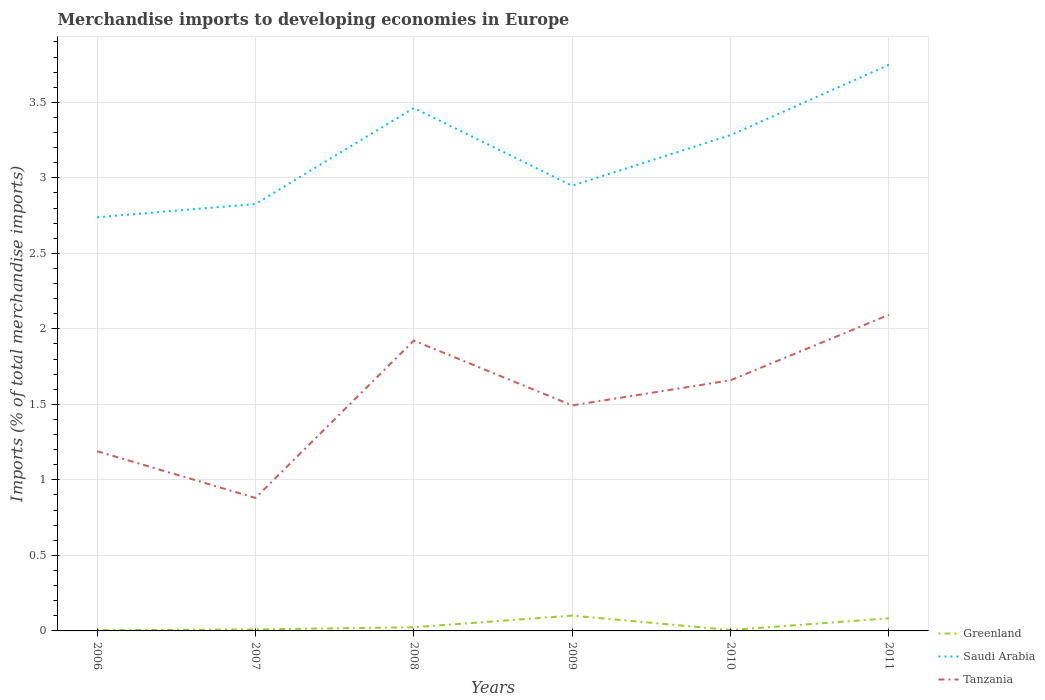Does the line corresponding to Saudi Arabia intersect with the line corresponding to Greenland?
Your answer should be compact. No. Across all years, what is the maximum percentage total merchandise imports in Tanzania?
Make the answer very short. 0.88. In which year was the percentage total merchandise imports in Greenland maximum?
Your response must be concise. 2006. What is the total percentage total merchandise imports in Saudi Arabia in the graph?
Keep it short and to the point. -0.54. What is the difference between the highest and the second highest percentage total merchandise imports in Saudi Arabia?
Your response must be concise. 1.01. What is the difference between the highest and the lowest percentage total merchandise imports in Greenland?
Offer a very short reply. 2. Is the percentage total merchandise imports in Greenland strictly greater than the percentage total merchandise imports in Tanzania over the years?
Your answer should be compact. Yes. How many years are there in the graph?
Provide a short and direct response. 6. What is the difference between two consecutive major ticks on the Y-axis?
Offer a very short reply. 0.5. Does the graph contain any zero values?
Ensure brevity in your answer.  No. Does the graph contain grids?
Ensure brevity in your answer.  Yes. Where does the legend appear in the graph?
Keep it short and to the point. Bottom right. How are the legend labels stacked?
Provide a succinct answer. Vertical. What is the title of the graph?
Offer a very short reply. Merchandise imports to developing economies in Europe. Does "Brazil" appear as one of the legend labels in the graph?
Provide a short and direct response. No. What is the label or title of the Y-axis?
Your answer should be compact. Imports (% of total merchandise imports). What is the Imports (% of total merchandise imports) of Greenland in 2006?
Ensure brevity in your answer.  0.01. What is the Imports (% of total merchandise imports) in Saudi Arabia in 2006?
Your answer should be compact. 2.74. What is the Imports (% of total merchandise imports) of Tanzania in 2006?
Offer a very short reply. 1.19. What is the Imports (% of total merchandise imports) in Greenland in 2007?
Make the answer very short. 0.01. What is the Imports (% of total merchandise imports) in Saudi Arabia in 2007?
Make the answer very short. 2.83. What is the Imports (% of total merchandise imports) in Tanzania in 2007?
Ensure brevity in your answer.  0.88. What is the Imports (% of total merchandise imports) of Greenland in 2008?
Your response must be concise. 0.02. What is the Imports (% of total merchandise imports) in Saudi Arabia in 2008?
Your answer should be very brief. 3.46. What is the Imports (% of total merchandise imports) in Tanzania in 2008?
Offer a very short reply. 1.92. What is the Imports (% of total merchandise imports) in Greenland in 2009?
Provide a short and direct response. 0.1. What is the Imports (% of total merchandise imports) of Saudi Arabia in 2009?
Provide a short and direct response. 2.95. What is the Imports (% of total merchandise imports) in Tanzania in 2009?
Offer a terse response. 1.49. What is the Imports (% of total merchandise imports) of Greenland in 2010?
Keep it short and to the point. 0.01. What is the Imports (% of total merchandise imports) in Saudi Arabia in 2010?
Ensure brevity in your answer.  3.28. What is the Imports (% of total merchandise imports) in Tanzania in 2010?
Give a very brief answer. 1.66. What is the Imports (% of total merchandise imports) of Greenland in 2011?
Provide a succinct answer. 0.08. What is the Imports (% of total merchandise imports) in Saudi Arabia in 2011?
Your answer should be compact. 3.75. What is the Imports (% of total merchandise imports) in Tanzania in 2011?
Your answer should be very brief. 2.09. Across all years, what is the maximum Imports (% of total merchandise imports) of Greenland?
Your response must be concise. 0.1. Across all years, what is the maximum Imports (% of total merchandise imports) in Saudi Arabia?
Your answer should be very brief. 3.75. Across all years, what is the maximum Imports (% of total merchandise imports) in Tanzania?
Make the answer very short. 2.09. Across all years, what is the minimum Imports (% of total merchandise imports) in Greenland?
Provide a succinct answer. 0.01. Across all years, what is the minimum Imports (% of total merchandise imports) of Saudi Arabia?
Your response must be concise. 2.74. Across all years, what is the minimum Imports (% of total merchandise imports) in Tanzania?
Your answer should be compact. 0.88. What is the total Imports (% of total merchandise imports) in Greenland in the graph?
Your answer should be very brief. 0.23. What is the total Imports (% of total merchandise imports) of Saudi Arabia in the graph?
Your answer should be compact. 19.01. What is the total Imports (% of total merchandise imports) in Tanzania in the graph?
Offer a terse response. 9.24. What is the difference between the Imports (% of total merchandise imports) in Greenland in 2006 and that in 2007?
Make the answer very short. -0. What is the difference between the Imports (% of total merchandise imports) of Saudi Arabia in 2006 and that in 2007?
Provide a short and direct response. -0.09. What is the difference between the Imports (% of total merchandise imports) of Tanzania in 2006 and that in 2007?
Offer a terse response. 0.31. What is the difference between the Imports (% of total merchandise imports) in Greenland in 2006 and that in 2008?
Give a very brief answer. -0.02. What is the difference between the Imports (% of total merchandise imports) in Saudi Arabia in 2006 and that in 2008?
Keep it short and to the point. -0.72. What is the difference between the Imports (% of total merchandise imports) of Tanzania in 2006 and that in 2008?
Your response must be concise. -0.73. What is the difference between the Imports (% of total merchandise imports) in Greenland in 2006 and that in 2009?
Provide a short and direct response. -0.1. What is the difference between the Imports (% of total merchandise imports) in Saudi Arabia in 2006 and that in 2009?
Offer a terse response. -0.21. What is the difference between the Imports (% of total merchandise imports) of Tanzania in 2006 and that in 2009?
Offer a terse response. -0.3. What is the difference between the Imports (% of total merchandise imports) of Greenland in 2006 and that in 2010?
Keep it short and to the point. -0. What is the difference between the Imports (% of total merchandise imports) in Saudi Arabia in 2006 and that in 2010?
Make the answer very short. -0.54. What is the difference between the Imports (% of total merchandise imports) of Tanzania in 2006 and that in 2010?
Ensure brevity in your answer.  -0.47. What is the difference between the Imports (% of total merchandise imports) in Greenland in 2006 and that in 2011?
Provide a short and direct response. -0.08. What is the difference between the Imports (% of total merchandise imports) in Saudi Arabia in 2006 and that in 2011?
Provide a short and direct response. -1.01. What is the difference between the Imports (% of total merchandise imports) of Tanzania in 2006 and that in 2011?
Give a very brief answer. -0.9. What is the difference between the Imports (% of total merchandise imports) of Greenland in 2007 and that in 2008?
Give a very brief answer. -0.01. What is the difference between the Imports (% of total merchandise imports) of Saudi Arabia in 2007 and that in 2008?
Your answer should be very brief. -0.64. What is the difference between the Imports (% of total merchandise imports) of Tanzania in 2007 and that in 2008?
Provide a succinct answer. -1.04. What is the difference between the Imports (% of total merchandise imports) in Greenland in 2007 and that in 2009?
Keep it short and to the point. -0.09. What is the difference between the Imports (% of total merchandise imports) in Saudi Arabia in 2007 and that in 2009?
Offer a terse response. -0.12. What is the difference between the Imports (% of total merchandise imports) in Tanzania in 2007 and that in 2009?
Ensure brevity in your answer.  -0.61. What is the difference between the Imports (% of total merchandise imports) in Greenland in 2007 and that in 2010?
Offer a very short reply. 0. What is the difference between the Imports (% of total merchandise imports) in Saudi Arabia in 2007 and that in 2010?
Provide a short and direct response. -0.46. What is the difference between the Imports (% of total merchandise imports) in Tanzania in 2007 and that in 2010?
Provide a short and direct response. -0.78. What is the difference between the Imports (% of total merchandise imports) of Greenland in 2007 and that in 2011?
Make the answer very short. -0.07. What is the difference between the Imports (% of total merchandise imports) of Saudi Arabia in 2007 and that in 2011?
Provide a short and direct response. -0.92. What is the difference between the Imports (% of total merchandise imports) in Tanzania in 2007 and that in 2011?
Your answer should be compact. -1.21. What is the difference between the Imports (% of total merchandise imports) of Greenland in 2008 and that in 2009?
Offer a very short reply. -0.08. What is the difference between the Imports (% of total merchandise imports) of Saudi Arabia in 2008 and that in 2009?
Provide a succinct answer. 0.51. What is the difference between the Imports (% of total merchandise imports) of Tanzania in 2008 and that in 2009?
Your response must be concise. 0.43. What is the difference between the Imports (% of total merchandise imports) of Greenland in 2008 and that in 2010?
Your answer should be very brief. 0.02. What is the difference between the Imports (% of total merchandise imports) of Saudi Arabia in 2008 and that in 2010?
Provide a succinct answer. 0.18. What is the difference between the Imports (% of total merchandise imports) in Tanzania in 2008 and that in 2010?
Give a very brief answer. 0.26. What is the difference between the Imports (% of total merchandise imports) of Greenland in 2008 and that in 2011?
Offer a terse response. -0.06. What is the difference between the Imports (% of total merchandise imports) of Saudi Arabia in 2008 and that in 2011?
Offer a terse response. -0.29. What is the difference between the Imports (% of total merchandise imports) in Tanzania in 2008 and that in 2011?
Make the answer very short. -0.17. What is the difference between the Imports (% of total merchandise imports) of Greenland in 2009 and that in 2010?
Give a very brief answer. 0.1. What is the difference between the Imports (% of total merchandise imports) of Saudi Arabia in 2009 and that in 2010?
Your answer should be compact. -0.33. What is the difference between the Imports (% of total merchandise imports) in Tanzania in 2009 and that in 2010?
Ensure brevity in your answer.  -0.17. What is the difference between the Imports (% of total merchandise imports) in Greenland in 2009 and that in 2011?
Your answer should be compact. 0.02. What is the difference between the Imports (% of total merchandise imports) in Saudi Arabia in 2009 and that in 2011?
Make the answer very short. -0.8. What is the difference between the Imports (% of total merchandise imports) in Tanzania in 2009 and that in 2011?
Ensure brevity in your answer.  -0.6. What is the difference between the Imports (% of total merchandise imports) of Greenland in 2010 and that in 2011?
Offer a terse response. -0.08. What is the difference between the Imports (% of total merchandise imports) in Saudi Arabia in 2010 and that in 2011?
Your response must be concise. -0.47. What is the difference between the Imports (% of total merchandise imports) of Tanzania in 2010 and that in 2011?
Keep it short and to the point. -0.43. What is the difference between the Imports (% of total merchandise imports) in Greenland in 2006 and the Imports (% of total merchandise imports) in Saudi Arabia in 2007?
Ensure brevity in your answer.  -2.82. What is the difference between the Imports (% of total merchandise imports) in Greenland in 2006 and the Imports (% of total merchandise imports) in Tanzania in 2007?
Ensure brevity in your answer.  -0.88. What is the difference between the Imports (% of total merchandise imports) of Saudi Arabia in 2006 and the Imports (% of total merchandise imports) of Tanzania in 2007?
Provide a succinct answer. 1.86. What is the difference between the Imports (% of total merchandise imports) in Greenland in 2006 and the Imports (% of total merchandise imports) in Saudi Arabia in 2008?
Provide a short and direct response. -3.46. What is the difference between the Imports (% of total merchandise imports) in Greenland in 2006 and the Imports (% of total merchandise imports) in Tanzania in 2008?
Offer a terse response. -1.92. What is the difference between the Imports (% of total merchandise imports) of Saudi Arabia in 2006 and the Imports (% of total merchandise imports) of Tanzania in 2008?
Your response must be concise. 0.82. What is the difference between the Imports (% of total merchandise imports) of Greenland in 2006 and the Imports (% of total merchandise imports) of Saudi Arabia in 2009?
Your answer should be compact. -2.94. What is the difference between the Imports (% of total merchandise imports) in Greenland in 2006 and the Imports (% of total merchandise imports) in Tanzania in 2009?
Provide a succinct answer. -1.49. What is the difference between the Imports (% of total merchandise imports) of Saudi Arabia in 2006 and the Imports (% of total merchandise imports) of Tanzania in 2009?
Make the answer very short. 1.25. What is the difference between the Imports (% of total merchandise imports) of Greenland in 2006 and the Imports (% of total merchandise imports) of Saudi Arabia in 2010?
Give a very brief answer. -3.28. What is the difference between the Imports (% of total merchandise imports) of Greenland in 2006 and the Imports (% of total merchandise imports) of Tanzania in 2010?
Provide a short and direct response. -1.65. What is the difference between the Imports (% of total merchandise imports) of Saudi Arabia in 2006 and the Imports (% of total merchandise imports) of Tanzania in 2010?
Your answer should be very brief. 1.08. What is the difference between the Imports (% of total merchandise imports) of Greenland in 2006 and the Imports (% of total merchandise imports) of Saudi Arabia in 2011?
Offer a terse response. -3.74. What is the difference between the Imports (% of total merchandise imports) in Greenland in 2006 and the Imports (% of total merchandise imports) in Tanzania in 2011?
Give a very brief answer. -2.09. What is the difference between the Imports (% of total merchandise imports) of Saudi Arabia in 2006 and the Imports (% of total merchandise imports) of Tanzania in 2011?
Ensure brevity in your answer.  0.65. What is the difference between the Imports (% of total merchandise imports) of Greenland in 2007 and the Imports (% of total merchandise imports) of Saudi Arabia in 2008?
Give a very brief answer. -3.45. What is the difference between the Imports (% of total merchandise imports) of Greenland in 2007 and the Imports (% of total merchandise imports) of Tanzania in 2008?
Provide a succinct answer. -1.91. What is the difference between the Imports (% of total merchandise imports) in Saudi Arabia in 2007 and the Imports (% of total merchandise imports) in Tanzania in 2008?
Offer a terse response. 0.9. What is the difference between the Imports (% of total merchandise imports) in Greenland in 2007 and the Imports (% of total merchandise imports) in Saudi Arabia in 2009?
Offer a very short reply. -2.94. What is the difference between the Imports (% of total merchandise imports) in Greenland in 2007 and the Imports (% of total merchandise imports) in Tanzania in 2009?
Your response must be concise. -1.48. What is the difference between the Imports (% of total merchandise imports) of Saudi Arabia in 2007 and the Imports (% of total merchandise imports) of Tanzania in 2009?
Make the answer very short. 1.33. What is the difference between the Imports (% of total merchandise imports) in Greenland in 2007 and the Imports (% of total merchandise imports) in Saudi Arabia in 2010?
Your answer should be very brief. -3.27. What is the difference between the Imports (% of total merchandise imports) in Greenland in 2007 and the Imports (% of total merchandise imports) in Tanzania in 2010?
Provide a short and direct response. -1.65. What is the difference between the Imports (% of total merchandise imports) of Saudi Arabia in 2007 and the Imports (% of total merchandise imports) of Tanzania in 2010?
Offer a very short reply. 1.17. What is the difference between the Imports (% of total merchandise imports) of Greenland in 2007 and the Imports (% of total merchandise imports) of Saudi Arabia in 2011?
Your response must be concise. -3.74. What is the difference between the Imports (% of total merchandise imports) of Greenland in 2007 and the Imports (% of total merchandise imports) of Tanzania in 2011?
Your response must be concise. -2.08. What is the difference between the Imports (% of total merchandise imports) in Saudi Arabia in 2007 and the Imports (% of total merchandise imports) in Tanzania in 2011?
Keep it short and to the point. 0.73. What is the difference between the Imports (% of total merchandise imports) of Greenland in 2008 and the Imports (% of total merchandise imports) of Saudi Arabia in 2009?
Your answer should be very brief. -2.92. What is the difference between the Imports (% of total merchandise imports) in Greenland in 2008 and the Imports (% of total merchandise imports) in Tanzania in 2009?
Give a very brief answer. -1.47. What is the difference between the Imports (% of total merchandise imports) in Saudi Arabia in 2008 and the Imports (% of total merchandise imports) in Tanzania in 2009?
Offer a terse response. 1.97. What is the difference between the Imports (% of total merchandise imports) in Greenland in 2008 and the Imports (% of total merchandise imports) in Saudi Arabia in 2010?
Offer a terse response. -3.26. What is the difference between the Imports (% of total merchandise imports) in Greenland in 2008 and the Imports (% of total merchandise imports) in Tanzania in 2010?
Your answer should be compact. -1.64. What is the difference between the Imports (% of total merchandise imports) of Saudi Arabia in 2008 and the Imports (% of total merchandise imports) of Tanzania in 2010?
Make the answer very short. 1.8. What is the difference between the Imports (% of total merchandise imports) in Greenland in 2008 and the Imports (% of total merchandise imports) in Saudi Arabia in 2011?
Keep it short and to the point. -3.72. What is the difference between the Imports (% of total merchandise imports) in Greenland in 2008 and the Imports (% of total merchandise imports) in Tanzania in 2011?
Keep it short and to the point. -2.07. What is the difference between the Imports (% of total merchandise imports) of Saudi Arabia in 2008 and the Imports (% of total merchandise imports) of Tanzania in 2011?
Give a very brief answer. 1.37. What is the difference between the Imports (% of total merchandise imports) of Greenland in 2009 and the Imports (% of total merchandise imports) of Saudi Arabia in 2010?
Provide a short and direct response. -3.18. What is the difference between the Imports (% of total merchandise imports) in Greenland in 2009 and the Imports (% of total merchandise imports) in Tanzania in 2010?
Your answer should be compact. -1.56. What is the difference between the Imports (% of total merchandise imports) of Saudi Arabia in 2009 and the Imports (% of total merchandise imports) of Tanzania in 2010?
Provide a short and direct response. 1.29. What is the difference between the Imports (% of total merchandise imports) of Greenland in 2009 and the Imports (% of total merchandise imports) of Saudi Arabia in 2011?
Your answer should be very brief. -3.65. What is the difference between the Imports (% of total merchandise imports) of Greenland in 2009 and the Imports (% of total merchandise imports) of Tanzania in 2011?
Your answer should be very brief. -1.99. What is the difference between the Imports (% of total merchandise imports) in Saudi Arabia in 2009 and the Imports (% of total merchandise imports) in Tanzania in 2011?
Your answer should be very brief. 0.85. What is the difference between the Imports (% of total merchandise imports) of Greenland in 2010 and the Imports (% of total merchandise imports) of Saudi Arabia in 2011?
Give a very brief answer. -3.74. What is the difference between the Imports (% of total merchandise imports) in Greenland in 2010 and the Imports (% of total merchandise imports) in Tanzania in 2011?
Ensure brevity in your answer.  -2.09. What is the difference between the Imports (% of total merchandise imports) of Saudi Arabia in 2010 and the Imports (% of total merchandise imports) of Tanzania in 2011?
Provide a succinct answer. 1.19. What is the average Imports (% of total merchandise imports) in Greenland per year?
Offer a terse response. 0.04. What is the average Imports (% of total merchandise imports) of Saudi Arabia per year?
Keep it short and to the point. 3.17. What is the average Imports (% of total merchandise imports) in Tanzania per year?
Make the answer very short. 1.54. In the year 2006, what is the difference between the Imports (% of total merchandise imports) of Greenland and Imports (% of total merchandise imports) of Saudi Arabia?
Your answer should be compact. -2.73. In the year 2006, what is the difference between the Imports (% of total merchandise imports) of Greenland and Imports (% of total merchandise imports) of Tanzania?
Provide a short and direct response. -1.18. In the year 2006, what is the difference between the Imports (% of total merchandise imports) of Saudi Arabia and Imports (% of total merchandise imports) of Tanzania?
Your response must be concise. 1.55. In the year 2007, what is the difference between the Imports (% of total merchandise imports) of Greenland and Imports (% of total merchandise imports) of Saudi Arabia?
Make the answer very short. -2.82. In the year 2007, what is the difference between the Imports (% of total merchandise imports) of Greenland and Imports (% of total merchandise imports) of Tanzania?
Offer a terse response. -0.87. In the year 2007, what is the difference between the Imports (% of total merchandise imports) of Saudi Arabia and Imports (% of total merchandise imports) of Tanzania?
Provide a succinct answer. 1.95. In the year 2008, what is the difference between the Imports (% of total merchandise imports) in Greenland and Imports (% of total merchandise imports) in Saudi Arabia?
Provide a succinct answer. -3.44. In the year 2008, what is the difference between the Imports (% of total merchandise imports) in Greenland and Imports (% of total merchandise imports) in Tanzania?
Make the answer very short. -1.9. In the year 2008, what is the difference between the Imports (% of total merchandise imports) of Saudi Arabia and Imports (% of total merchandise imports) of Tanzania?
Offer a terse response. 1.54. In the year 2009, what is the difference between the Imports (% of total merchandise imports) in Greenland and Imports (% of total merchandise imports) in Saudi Arabia?
Make the answer very short. -2.85. In the year 2009, what is the difference between the Imports (% of total merchandise imports) in Greenland and Imports (% of total merchandise imports) in Tanzania?
Your answer should be compact. -1.39. In the year 2009, what is the difference between the Imports (% of total merchandise imports) in Saudi Arabia and Imports (% of total merchandise imports) in Tanzania?
Provide a short and direct response. 1.45. In the year 2010, what is the difference between the Imports (% of total merchandise imports) of Greenland and Imports (% of total merchandise imports) of Saudi Arabia?
Make the answer very short. -3.28. In the year 2010, what is the difference between the Imports (% of total merchandise imports) of Greenland and Imports (% of total merchandise imports) of Tanzania?
Keep it short and to the point. -1.65. In the year 2010, what is the difference between the Imports (% of total merchandise imports) in Saudi Arabia and Imports (% of total merchandise imports) in Tanzania?
Keep it short and to the point. 1.62. In the year 2011, what is the difference between the Imports (% of total merchandise imports) of Greenland and Imports (% of total merchandise imports) of Saudi Arabia?
Your answer should be very brief. -3.66. In the year 2011, what is the difference between the Imports (% of total merchandise imports) of Greenland and Imports (% of total merchandise imports) of Tanzania?
Ensure brevity in your answer.  -2.01. In the year 2011, what is the difference between the Imports (% of total merchandise imports) in Saudi Arabia and Imports (% of total merchandise imports) in Tanzania?
Make the answer very short. 1.66. What is the ratio of the Imports (% of total merchandise imports) of Greenland in 2006 to that in 2007?
Ensure brevity in your answer.  0.51. What is the ratio of the Imports (% of total merchandise imports) in Saudi Arabia in 2006 to that in 2007?
Your response must be concise. 0.97. What is the ratio of the Imports (% of total merchandise imports) in Tanzania in 2006 to that in 2007?
Offer a terse response. 1.35. What is the ratio of the Imports (% of total merchandise imports) in Greenland in 2006 to that in 2008?
Offer a very short reply. 0.21. What is the ratio of the Imports (% of total merchandise imports) in Saudi Arabia in 2006 to that in 2008?
Provide a succinct answer. 0.79. What is the ratio of the Imports (% of total merchandise imports) of Tanzania in 2006 to that in 2008?
Your answer should be very brief. 0.62. What is the ratio of the Imports (% of total merchandise imports) of Greenland in 2006 to that in 2009?
Keep it short and to the point. 0.05. What is the ratio of the Imports (% of total merchandise imports) in Saudi Arabia in 2006 to that in 2009?
Keep it short and to the point. 0.93. What is the ratio of the Imports (% of total merchandise imports) in Tanzania in 2006 to that in 2009?
Your answer should be very brief. 0.8. What is the ratio of the Imports (% of total merchandise imports) in Greenland in 2006 to that in 2010?
Provide a succinct answer. 0.84. What is the ratio of the Imports (% of total merchandise imports) of Saudi Arabia in 2006 to that in 2010?
Offer a terse response. 0.83. What is the ratio of the Imports (% of total merchandise imports) in Tanzania in 2006 to that in 2010?
Provide a short and direct response. 0.72. What is the ratio of the Imports (% of total merchandise imports) in Greenland in 2006 to that in 2011?
Ensure brevity in your answer.  0.06. What is the ratio of the Imports (% of total merchandise imports) of Saudi Arabia in 2006 to that in 2011?
Ensure brevity in your answer.  0.73. What is the ratio of the Imports (% of total merchandise imports) in Tanzania in 2006 to that in 2011?
Your answer should be very brief. 0.57. What is the ratio of the Imports (% of total merchandise imports) in Greenland in 2007 to that in 2008?
Provide a succinct answer. 0.41. What is the ratio of the Imports (% of total merchandise imports) of Saudi Arabia in 2007 to that in 2008?
Keep it short and to the point. 0.82. What is the ratio of the Imports (% of total merchandise imports) in Tanzania in 2007 to that in 2008?
Give a very brief answer. 0.46. What is the ratio of the Imports (% of total merchandise imports) in Greenland in 2007 to that in 2009?
Give a very brief answer. 0.1. What is the ratio of the Imports (% of total merchandise imports) of Saudi Arabia in 2007 to that in 2009?
Your answer should be compact. 0.96. What is the ratio of the Imports (% of total merchandise imports) of Tanzania in 2007 to that in 2009?
Provide a short and direct response. 0.59. What is the ratio of the Imports (% of total merchandise imports) in Greenland in 2007 to that in 2010?
Offer a very short reply. 1.66. What is the ratio of the Imports (% of total merchandise imports) in Saudi Arabia in 2007 to that in 2010?
Offer a terse response. 0.86. What is the ratio of the Imports (% of total merchandise imports) of Tanzania in 2007 to that in 2010?
Your answer should be compact. 0.53. What is the ratio of the Imports (% of total merchandise imports) of Greenland in 2007 to that in 2011?
Offer a terse response. 0.12. What is the ratio of the Imports (% of total merchandise imports) of Saudi Arabia in 2007 to that in 2011?
Make the answer very short. 0.75. What is the ratio of the Imports (% of total merchandise imports) of Tanzania in 2007 to that in 2011?
Ensure brevity in your answer.  0.42. What is the ratio of the Imports (% of total merchandise imports) in Greenland in 2008 to that in 2009?
Give a very brief answer. 0.24. What is the ratio of the Imports (% of total merchandise imports) in Saudi Arabia in 2008 to that in 2009?
Make the answer very short. 1.17. What is the ratio of the Imports (% of total merchandise imports) of Tanzania in 2008 to that in 2009?
Provide a succinct answer. 1.29. What is the ratio of the Imports (% of total merchandise imports) in Greenland in 2008 to that in 2010?
Your response must be concise. 4.04. What is the ratio of the Imports (% of total merchandise imports) in Saudi Arabia in 2008 to that in 2010?
Offer a terse response. 1.05. What is the ratio of the Imports (% of total merchandise imports) in Tanzania in 2008 to that in 2010?
Give a very brief answer. 1.16. What is the ratio of the Imports (% of total merchandise imports) of Greenland in 2008 to that in 2011?
Make the answer very short. 0.29. What is the ratio of the Imports (% of total merchandise imports) in Saudi Arabia in 2008 to that in 2011?
Provide a short and direct response. 0.92. What is the ratio of the Imports (% of total merchandise imports) of Tanzania in 2008 to that in 2011?
Your response must be concise. 0.92. What is the ratio of the Imports (% of total merchandise imports) of Greenland in 2009 to that in 2010?
Make the answer very short. 16.83. What is the ratio of the Imports (% of total merchandise imports) of Saudi Arabia in 2009 to that in 2010?
Offer a very short reply. 0.9. What is the ratio of the Imports (% of total merchandise imports) of Tanzania in 2009 to that in 2010?
Ensure brevity in your answer.  0.9. What is the ratio of the Imports (% of total merchandise imports) in Greenland in 2009 to that in 2011?
Your answer should be very brief. 1.21. What is the ratio of the Imports (% of total merchandise imports) of Saudi Arabia in 2009 to that in 2011?
Keep it short and to the point. 0.79. What is the ratio of the Imports (% of total merchandise imports) in Tanzania in 2009 to that in 2011?
Provide a short and direct response. 0.71. What is the ratio of the Imports (% of total merchandise imports) of Greenland in 2010 to that in 2011?
Make the answer very short. 0.07. What is the ratio of the Imports (% of total merchandise imports) in Saudi Arabia in 2010 to that in 2011?
Your answer should be very brief. 0.88. What is the ratio of the Imports (% of total merchandise imports) in Tanzania in 2010 to that in 2011?
Provide a succinct answer. 0.79. What is the difference between the highest and the second highest Imports (% of total merchandise imports) in Greenland?
Provide a short and direct response. 0.02. What is the difference between the highest and the second highest Imports (% of total merchandise imports) of Saudi Arabia?
Keep it short and to the point. 0.29. What is the difference between the highest and the second highest Imports (% of total merchandise imports) in Tanzania?
Keep it short and to the point. 0.17. What is the difference between the highest and the lowest Imports (% of total merchandise imports) in Greenland?
Offer a terse response. 0.1. What is the difference between the highest and the lowest Imports (% of total merchandise imports) of Saudi Arabia?
Your response must be concise. 1.01. What is the difference between the highest and the lowest Imports (% of total merchandise imports) in Tanzania?
Your answer should be compact. 1.21. 